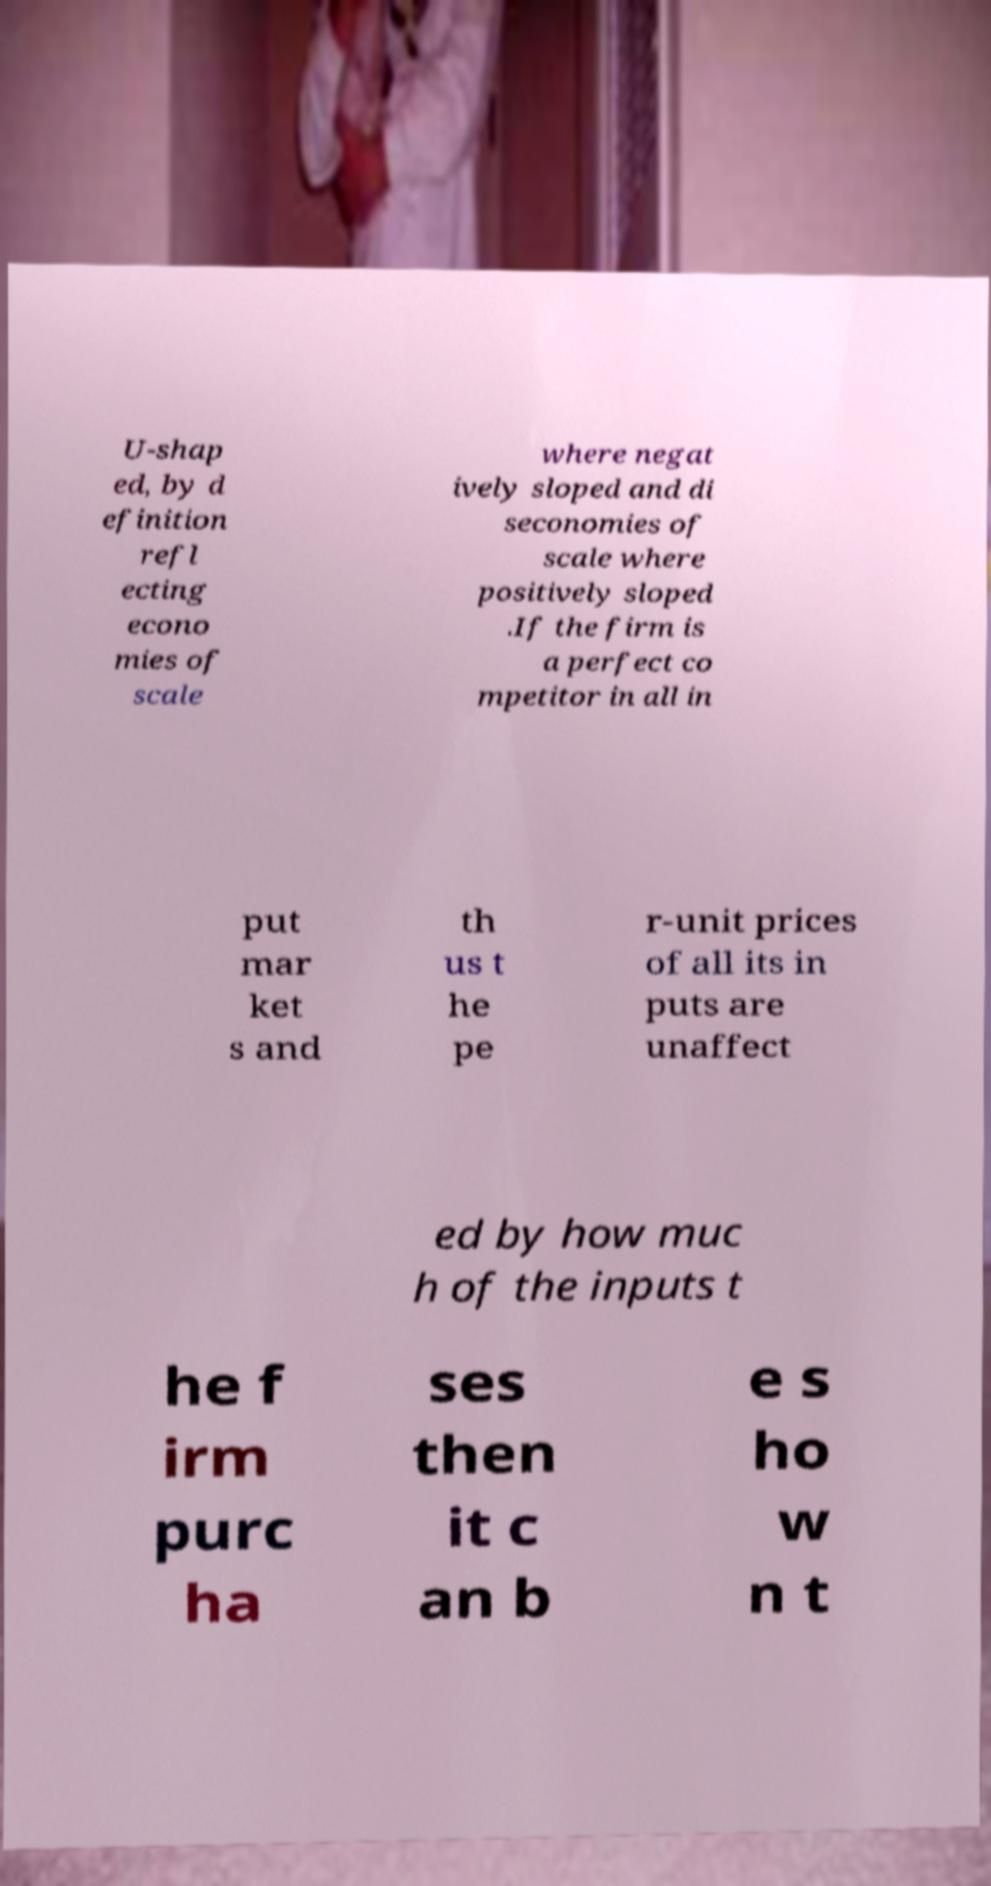Please read and relay the text visible in this image. What does it say? U-shap ed, by d efinition refl ecting econo mies of scale where negat ively sloped and di seconomies of scale where positively sloped .If the firm is a perfect co mpetitor in all in put mar ket s and th us t he pe r-unit prices of all its in puts are unaffect ed by how muc h of the inputs t he f irm purc ha ses then it c an b e s ho w n t 